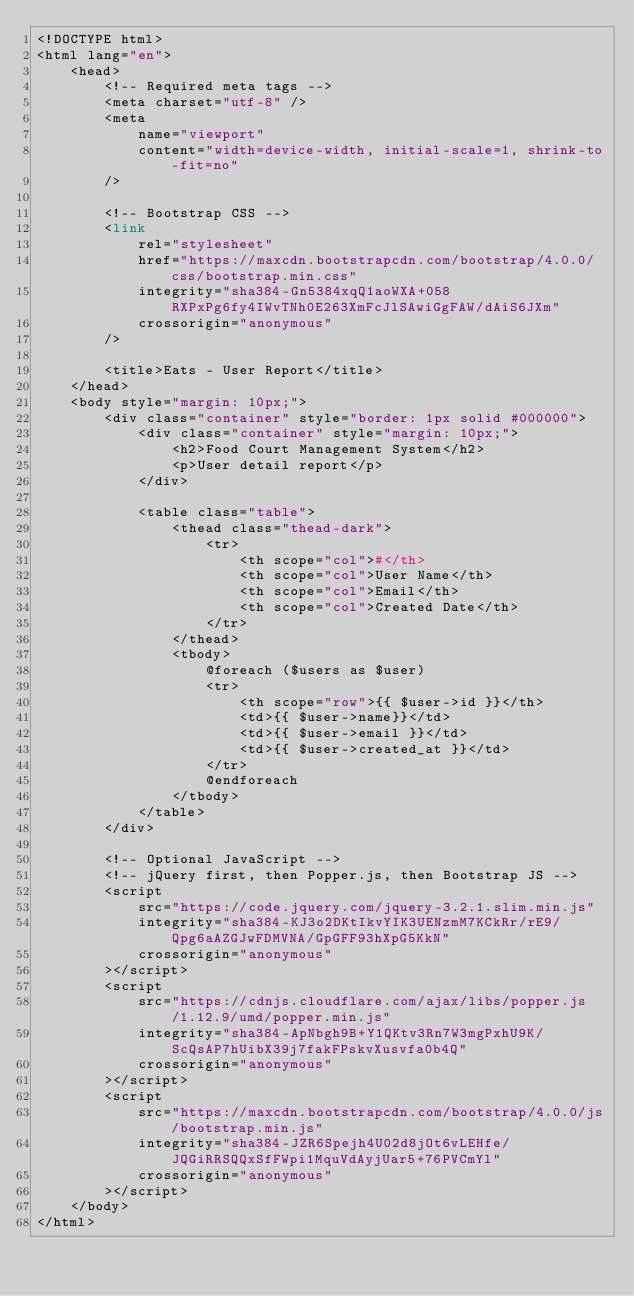Convert code to text. <code><loc_0><loc_0><loc_500><loc_500><_PHP_><!DOCTYPE html>
<html lang="en">
    <head>
        <!-- Required meta tags -->
        <meta charset="utf-8" />
        <meta
            name="viewport"
            content="width=device-width, initial-scale=1, shrink-to-fit=no"
        />

        <!-- Bootstrap CSS -->
        <link
            rel="stylesheet"
            href="https://maxcdn.bootstrapcdn.com/bootstrap/4.0.0/css/bootstrap.min.css"
            integrity="sha384-Gn5384xqQ1aoWXA+058RXPxPg6fy4IWvTNh0E263XmFcJlSAwiGgFAW/dAiS6JXm"
            crossorigin="anonymous"
        />

        <title>Eats - User Report</title>
    </head>
    <body style="margin: 10px;">
        <div class="container" style="border: 1px solid #000000">
            <div class="container" style="margin: 10px;">
                <h2>Food Court Management System</h2>
                <p>User detail report</p>
            </div>

            <table class="table">
                <thead class="thead-dark">
                    <tr>
                        <th scope="col">#</th>
                        <th scope="col">User Name</th>
                        <th scope="col">Email</th>
                        <th scope="col">Created Date</th>
                    </tr>
                </thead>
                <tbody>
                    @foreach ($users as $user)
                    <tr>
                        <th scope="row">{{ $user->id }}</th>
                        <td>{{ $user->name}}</td>
                        <td>{{ $user->email }}</td>
                        <td>{{ $user->created_at }}</td>
                    </tr>
                    @endforeach
                </tbody>
            </table>
        </div>

        <!-- Optional JavaScript -->
        <!-- jQuery first, then Popper.js, then Bootstrap JS -->
        <script
            src="https://code.jquery.com/jquery-3.2.1.slim.min.js"
            integrity="sha384-KJ3o2DKtIkvYIK3UENzmM7KCkRr/rE9/Qpg6aAZGJwFDMVNA/GpGFF93hXpG5KkN"
            crossorigin="anonymous"
        ></script>
        <script
            src="https://cdnjs.cloudflare.com/ajax/libs/popper.js/1.12.9/umd/popper.min.js"
            integrity="sha384-ApNbgh9B+Y1QKtv3Rn7W3mgPxhU9K/ScQsAP7hUibX39j7fakFPskvXusvfa0b4Q"
            crossorigin="anonymous"
        ></script>
        <script
            src="https://maxcdn.bootstrapcdn.com/bootstrap/4.0.0/js/bootstrap.min.js"
            integrity="sha384-JZR6Spejh4U02d8jOt6vLEHfe/JQGiRRSQQxSfFWpi1MquVdAyjUar5+76PVCmYl"
            crossorigin="anonymous"
        ></script>
    </body>
</html>
</code> 